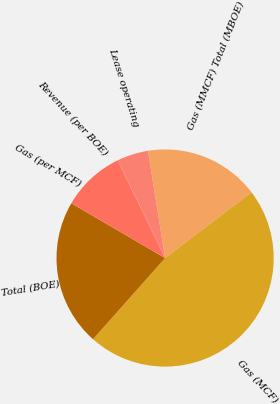Convert chart to OTSL. <chart><loc_0><loc_0><loc_500><loc_500><pie_chart><fcel>Gas (MMCF) Total (MBOE)<fcel>Gas (MCF)<fcel>Total (BOE)<fcel>Gas (per MCF)<fcel>Revenue (per BOE)<fcel>Lease operating<nl><fcel>17.17%<fcel>46.9%<fcel>21.86%<fcel>0.0%<fcel>9.38%<fcel>4.69%<nl></chart> 